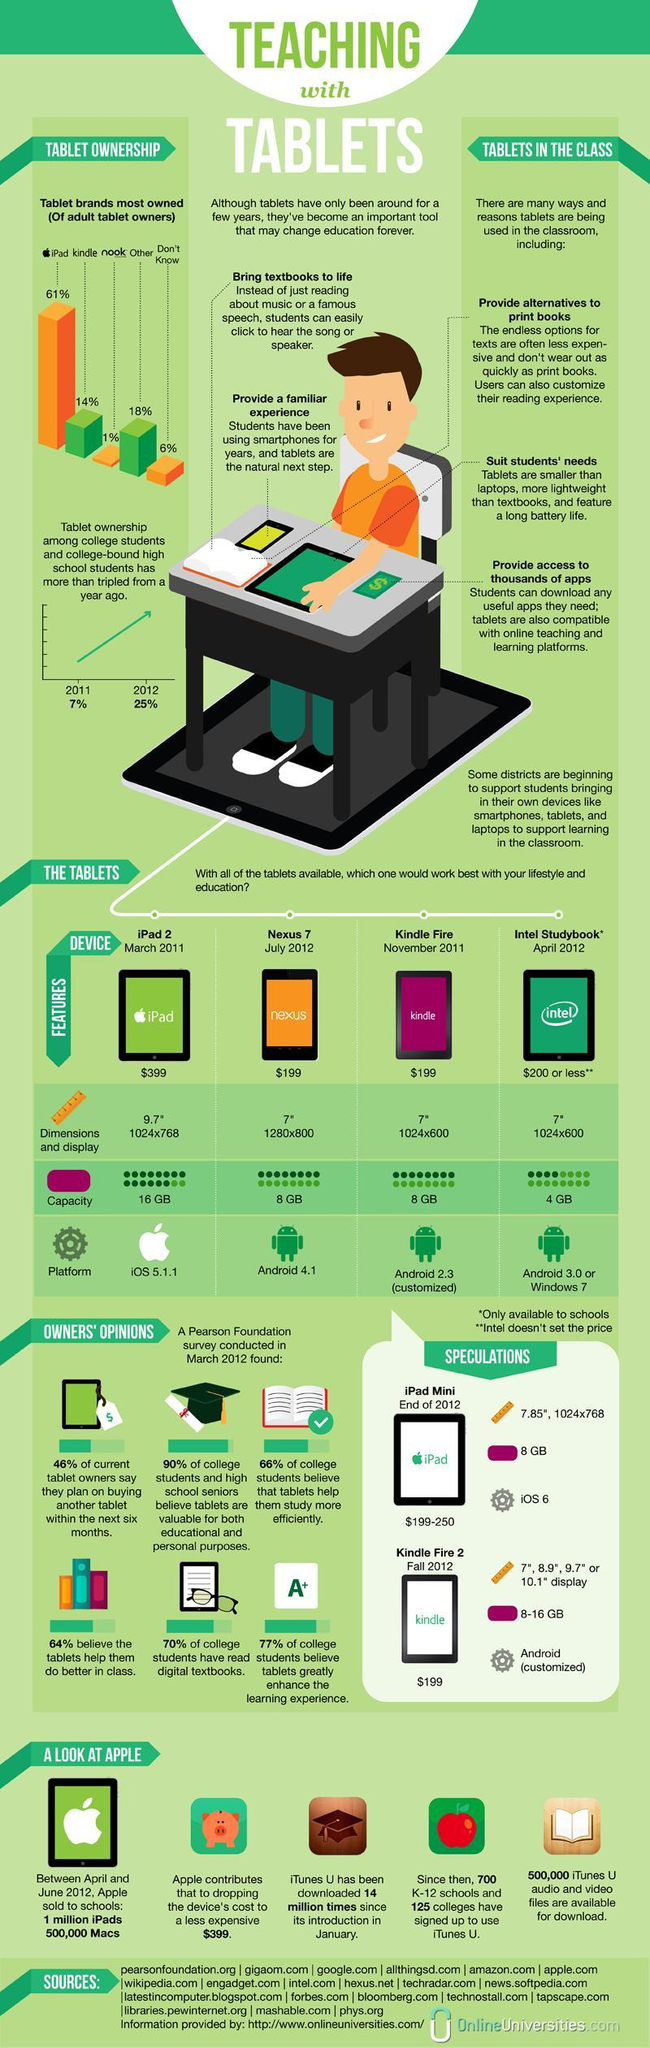Which tablet brand is least owned by adults?
Answer the question with a short phrase. nook Which tablet has a capacity of 16 GB? iPad 2 What percentage of college students have not read digital textbooks? 30% Nexus 7 uses which platform? Android 4.1 What is the capacity of Kindle Fire? 8 GB What is the capacity of the iPad 2? 16 GB What is the percentage growth of tablet owners among college students and college-bound high school students from 2011 to 2012? 18% 